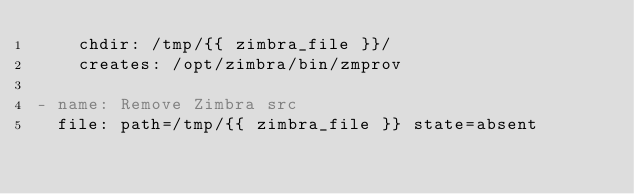<code> <loc_0><loc_0><loc_500><loc_500><_YAML_>    chdir: /tmp/{{ zimbra_file }}/
    creates: /opt/zimbra/bin/zmprov

- name: Remove Zimbra src
  file: path=/tmp/{{ zimbra_file }} state=absent
</code> 